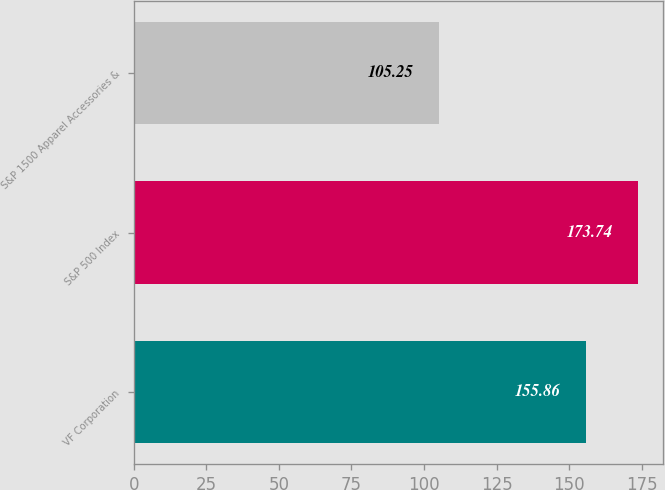<chart> <loc_0><loc_0><loc_500><loc_500><bar_chart><fcel>VF Corporation<fcel>S&P 500 Index<fcel>S&P 1500 Apparel Accessories &<nl><fcel>155.86<fcel>173.74<fcel>105.25<nl></chart> 